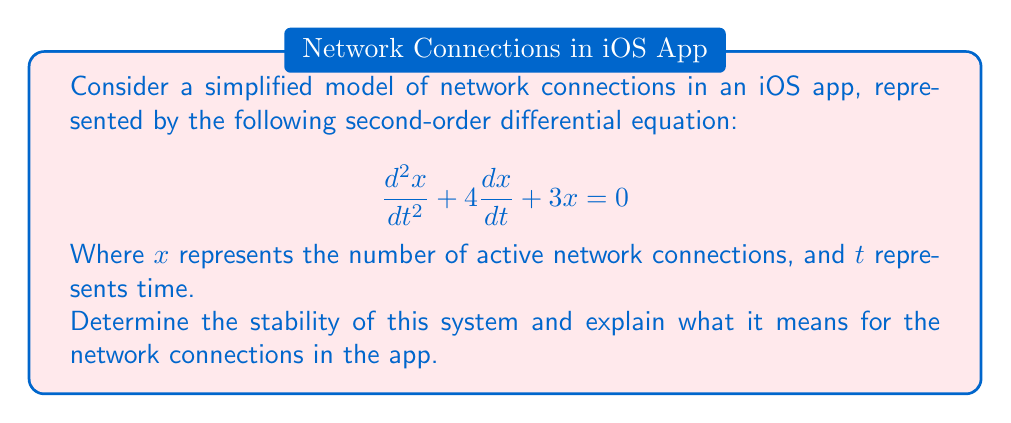Could you help me with this problem? To determine the stability of this system, we need to follow these steps:

1. Identify the characteristic equation:
   The general form of a second-order differential equation is:
   $$a\frac{d^2x}{dt^2} + b\frac{dx}{dt} + cx = 0$$
   In our case, $a=1$, $b=4$, and $c=3$.
   The characteristic equation is: $ar^2 + br + c = 0$

2. Solve the characteristic equation:
   $$r^2 + 4r + 3 = 0$$
   Using the quadratic formula: $r = \frac{-b \pm \sqrt{b^2 - 4ac}}{2a}$
   $$r = \frac{-4 \pm \sqrt{16 - 12}}{2} = \frac{-4 \pm \sqrt{4}}{2} = \frac{-4 \pm 2}{2}$$

3. Find the roots:
   $r_1 = \frac{-4 + 2}{2} = -1$
   $r_2 = \frac{-4 - 2}{2} = -3$

4. Analyze the roots:
   Both roots are real and negative.

5. Interpret the results:
   - Real roots indicate non-oscillatory behavior.
   - Negative roots indicate decay over time.
   - The system is stable because both roots are negative.

For the iOS app, this means:
- The number of active network connections will not oscillate.
- The number of connections will decrease over time, approaching zero.
- The system is stable, indicating that the number of connections won't grow uncontrollably.
Answer: The system is stable; network connections will decay non-oscillatorily. 